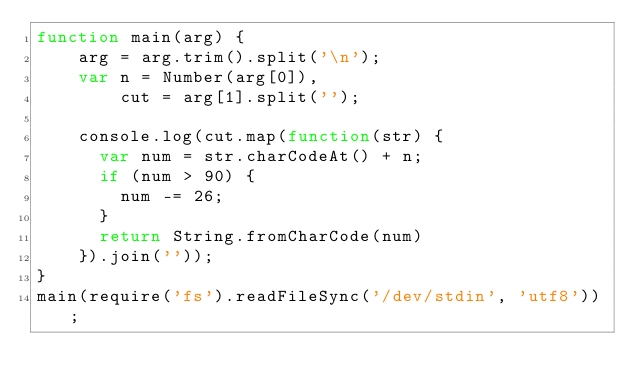Convert code to text. <code><loc_0><loc_0><loc_500><loc_500><_JavaScript_>function main(arg) {    
 	arg = arg.trim().split('\n');
 	var n = Number(arg[0]),
  		cut = arg[1].split('');
 
  	console.log(cut.map(function(str) {
      var num = str.charCodeAt() + n;
      if (num > 90) {
        num -= 26;
      }
      return String.fromCharCode(num)
    }).join(''));
}
main(require('fs').readFileSync('/dev/stdin', 'utf8'));</code> 